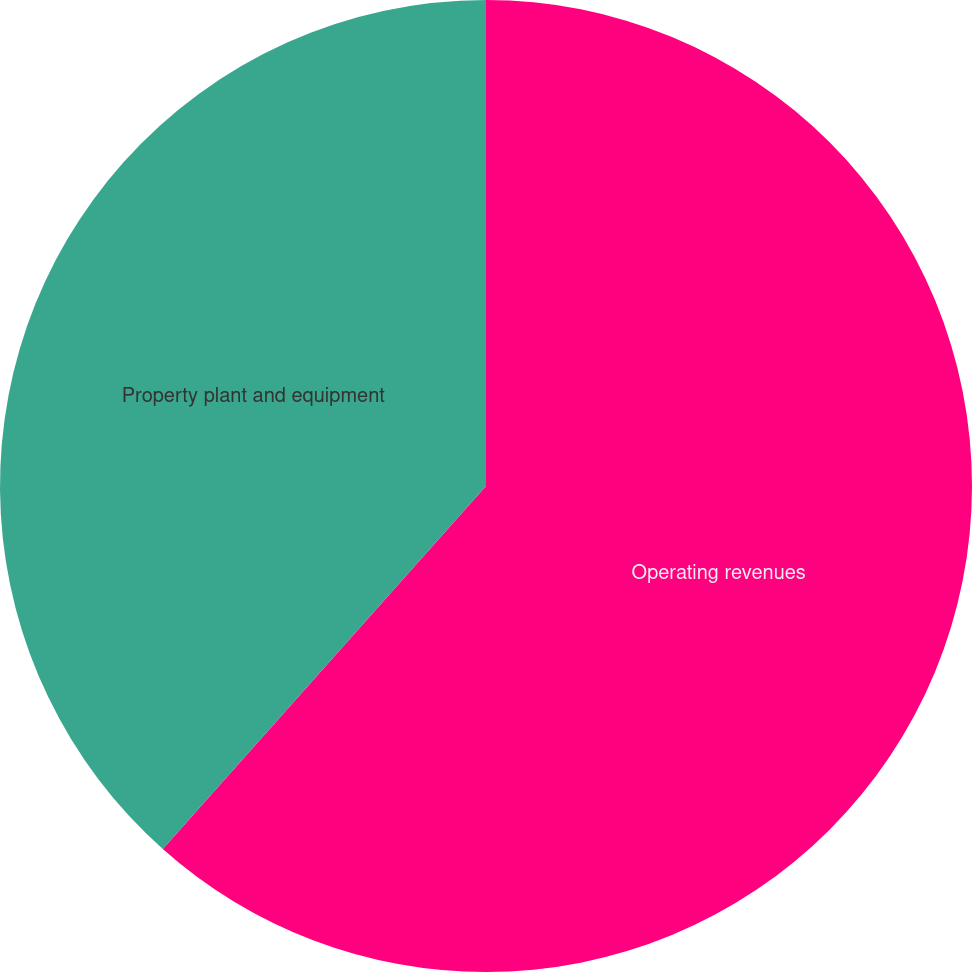Convert chart. <chart><loc_0><loc_0><loc_500><loc_500><pie_chart><fcel>Operating revenues<fcel>Property plant and equipment<nl><fcel>61.58%<fcel>38.42%<nl></chart> 